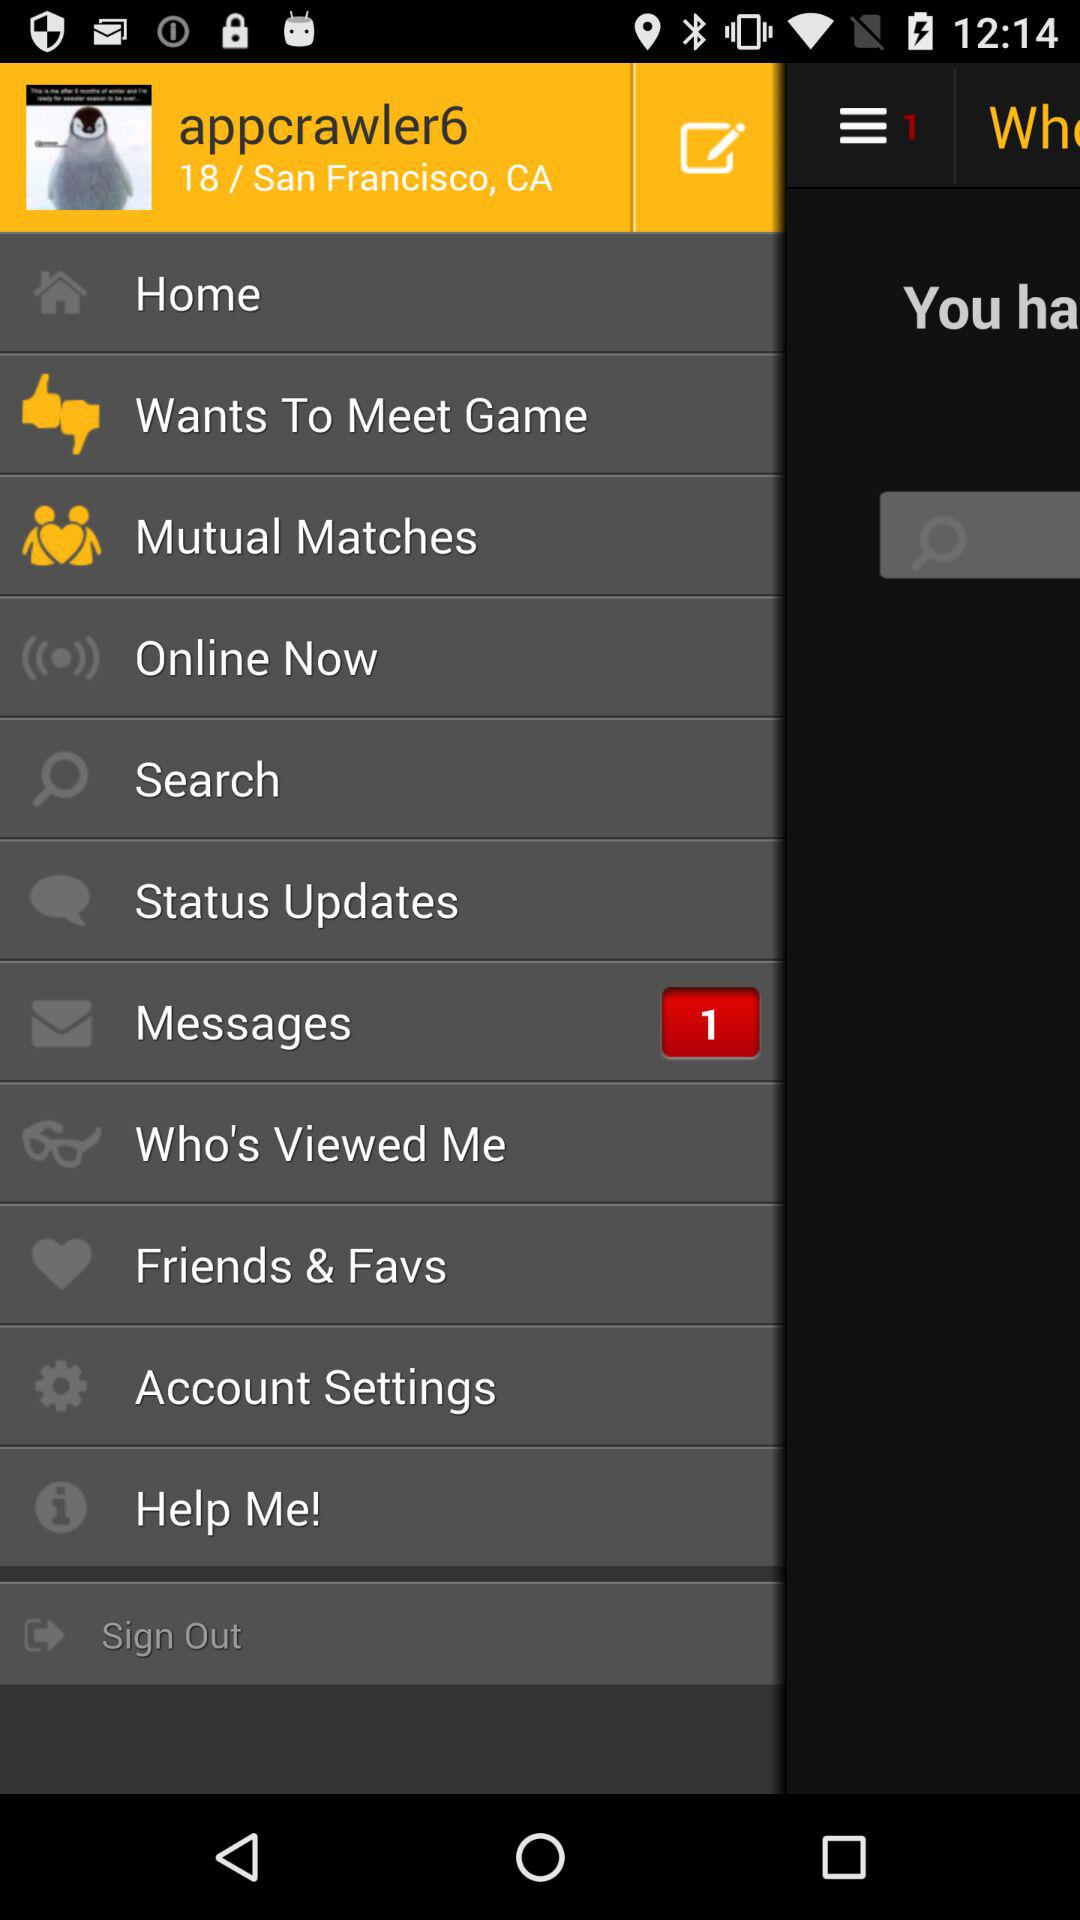What is the given location? The given location is San Francisco, CA. 